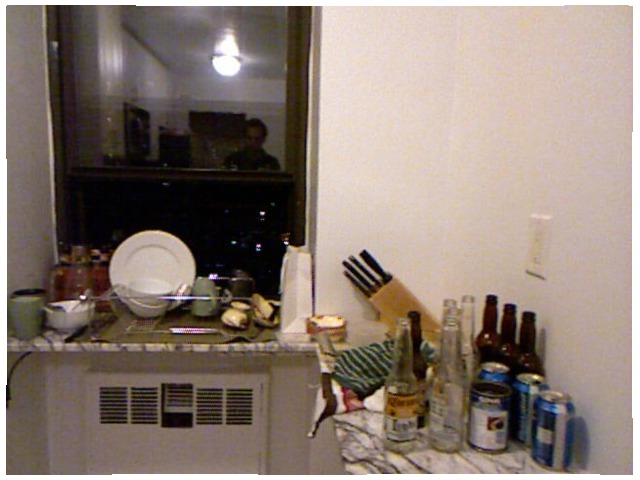<image>
Is there a man in front of the plate? Yes. The man is positioned in front of the plate, appearing closer to the camera viewpoint. Is there a outlet on the bottle? No. The outlet is not positioned on the bottle. They may be near each other, but the outlet is not supported by or resting on top of the bottle. Where is the knife in relation to the heater? Is it next to the heater? No. The knife is not positioned next to the heater. They are located in different areas of the scene. 